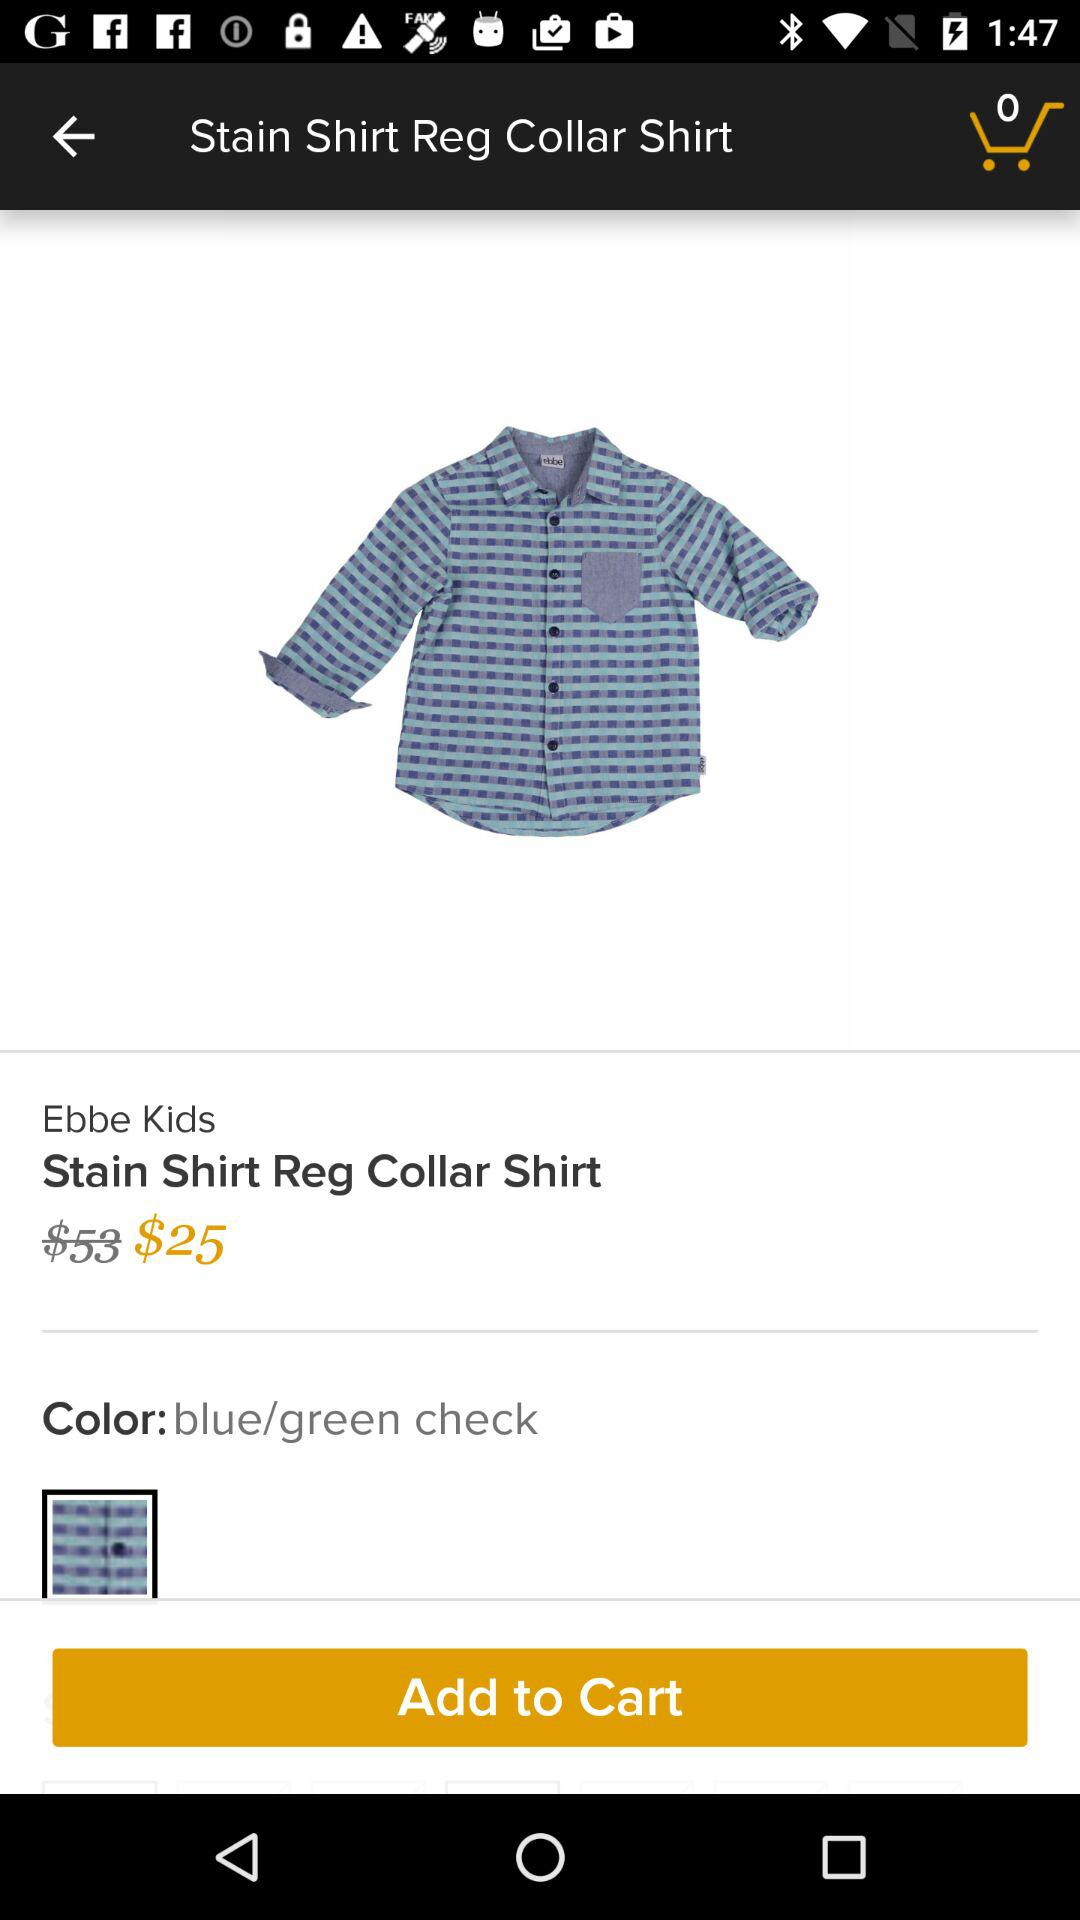How many items are there in the cart? There are 0 items. 